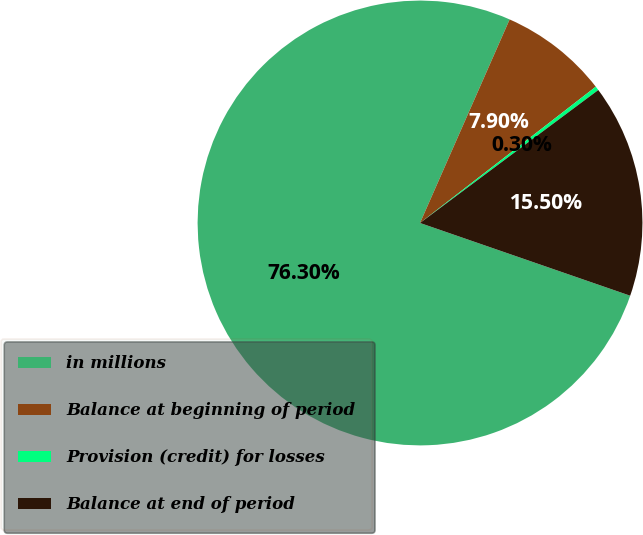Convert chart. <chart><loc_0><loc_0><loc_500><loc_500><pie_chart><fcel>in millions<fcel>Balance at beginning of period<fcel>Provision (credit) for losses<fcel>Balance at end of period<nl><fcel>76.29%<fcel>7.9%<fcel>0.3%<fcel>15.5%<nl></chart> 